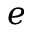Convert formula to latex. <formula><loc_0><loc_0><loc_500><loc_500>e</formula> 